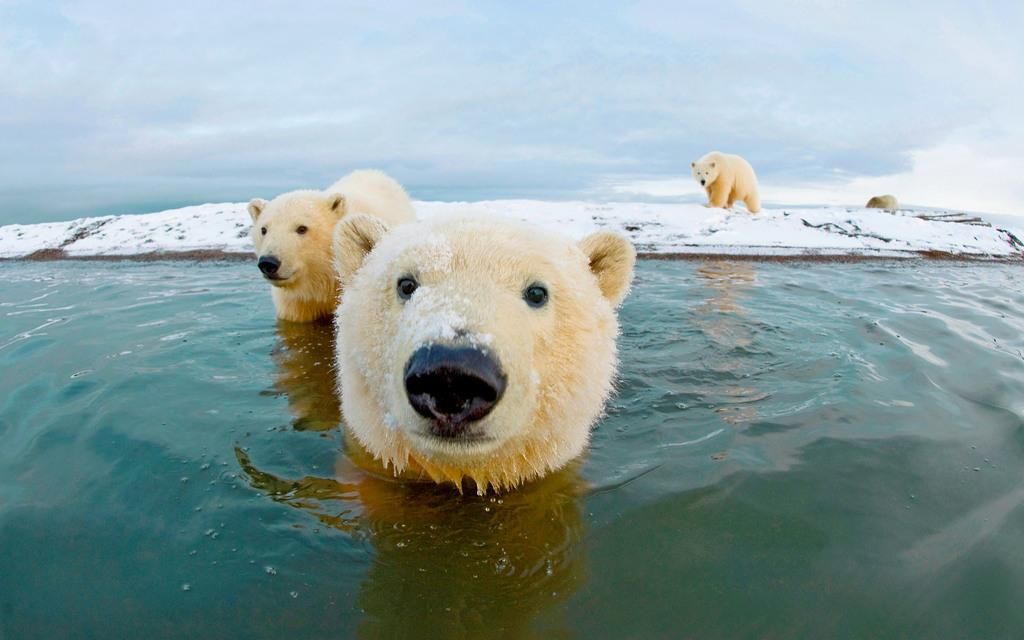What animals can be seen in the water in the image? There are two polar bears in the water in the image. How many polar bears are on the right side of the snow land? There are two polar bears on the right side of the snow land. What part of the natural environment is visible in the image? The sky is visible in the image. What can be observed in the sky? Clouds are present in the sky. Where is the shelf located in the image? There is no shelf present in the image. What type of pocket can be seen on the polar bears in the image? Polar bears do not have pockets, and there are no clothing items present in the image. 